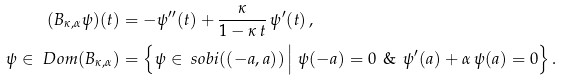<formula> <loc_0><loc_0><loc_500><loc_500>( B _ { \kappa , \alpha } \psi ) ( t ) & = - \psi ^ { \prime \prime } ( t ) + \frac { \kappa } { 1 - \kappa \, t } \, \psi ^ { \prime } ( t ) \, , \\ \psi \in \ D o m ( B _ { \kappa , \alpha } ) & = \Big \{ \psi \in \ s o b i ( ( - a , a ) ) \, \Big | \ \psi ( - a ) = 0 \ \, \& \ \, \psi ^ { \prime } ( a ) + \alpha \, \psi ( a ) = 0 \Big \} \, .</formula> 